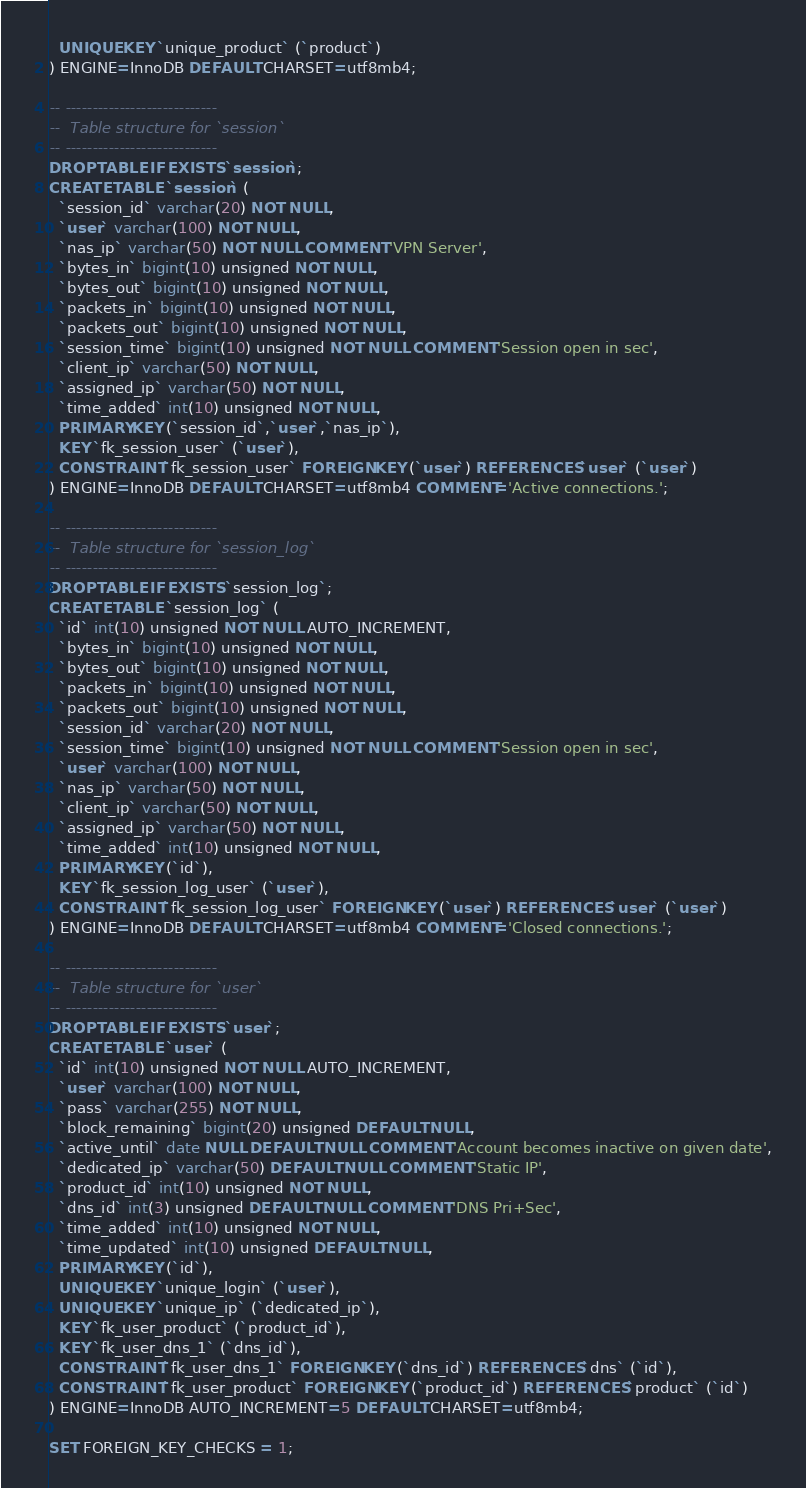<code> <loc_0><loc_0><loc_500><loc_500><_SQL_>  UNIQUE KEY `unique_product` (`product`)
) ENGINE=InnoDB DEFAULT CHARSET=utf8mb4;

-- ----------------------------
--  Table structure for `session`
-- ----------------------------
DROP TABLE IF EXISTS `session`;
CREATE TABLE `session` (
  `session_id` varchar(20) NOT NULL,
  `user` varchar(100) NOT NULL,
  `nas_ip` varchar(50) NOT NULL COMMENT 'VPN Server',
  `bytes_in` bigint(10) unsigned NOT NULL,
  `bytes_out` bigint(10) unsigned NOT NULL,
  `packets_in` bigint(10) unsigned NOT NULL,
  `packets_out` bigint(10) unsigned NOT NULL,
  `session_time` bigint(10) unsigned NOT NULL COMMENT 'Session open in sec',
  `client_ip` varchar(50) NOT NULL,
  `assigned_ip` varchar(50) NOT NULL,
  `time_added` int(10) unsigned NOT NULL,
  PRIMARY KEY (`session_id`,`user`,`nas_ip`),
  KEY `fk_session_user` (`user`),
  CONSTRAINT `fk_session_user` FOREIGN KEY (`user`) REFERENCES `user` (`user`)
) ENGINE=InnoDB DEFAULT CHARSET=utf8mb4 COMMENT='Active connections.';

-- ----------------------------
--  Table structure for `session_log`
-- ----------------------------
DROP TABLE IF EXISTS `session_log`;
CREATE TABLE `session_log` (
  `id` int(10) unsigned NOT NULL AUTO_INCREMENT,
  `bytes_in` bigint(10) unsigned NOT NULL,
  `bytes_out` bigint(10) unsigned NOT NULL,
  `packets_in` bigint(10) unsigned NOT NULL,
  `packets_out` bigint(10) unsigned NOT NULL,
  `session_id` varchar(20) NOT NULL,
  `session_time` bigint(10) unsigned NOT NULL COMMENT 'Session open in sec',
  `user` varchar(100) NOT NULL,
  `nas_ip` varchar(50) NOT NULL,
  `client_ip` varchar(50) NOT NULL,
  `assigned_ip` varchar(50) NOT NULL,
  `time_added` int(10) unsigned NOT NULL,
  PRIMARY KEY (`id`),
  KEY `fk_session_log_user` (`user`),
  CONSTRAINT `fk_session_log_user` FOREIGN KEY (`user`) REFERENCES `user` (`user`)
) ENGINE=InnoDB DEFAULT CHARSET=utf8mb4 COMMENT='Closed connections.';

-- ----------------------------
--  Table structure for `user`
-- ----------------------------
DROP TABLE IF EXISTS `user`;
CREATE TABLE `user` (
  `id` int(10) unsigned NOT NULL AUTO_INCREMENT,
  `user` varchar(100) NOT NULL,
  `pass` varchar(255) NOT NULL,
  `block_remaining` bigint(20) unsigned DEFAULT NULL,
  `active_until` date NULL DEFAULT NULL COMMENT 'Account becomes inactive on given date',
  `dedicated_ip` varchar(50) DEFAULT NULL COMMENT 'Static IP',
  `product_id` int(10) unsigned NOT NULL,
  `dns_id` int(3) unsigned DEFAULT NULL COMMENT 'DNS Pri+Sec',
  `time_added` int(10) unsigned NOT NULL,
  `time_updated` int(10) unsigned DEFAULT NULL,
  PRIMARY KEY (`id`),
  UNIQUE KEY `unique_login` (`user`),
  UNIQUE KEY `unique_ip` (`dedicated_ip`),
  KEY `fk_user_product` (`product_id`),
  KEY `fk_user_dns_1` (`dns_id`),
  CONSTRAINT `fk_user_dns_1` FOREIGN KEY (`dns_id`) REFERENCES `dns` (`id`),
  CONSTRAINT `fk_user_product` FOREIGN KEY (`product_id`) REFERENCES `product` (`id`)
) ENGINE=InnoDB AUTO_INCREMENT=5 DEFAULT CHARSET=utf8mb4;

SET FOREIGN_KEY_CHECKS = 1;
</code> 